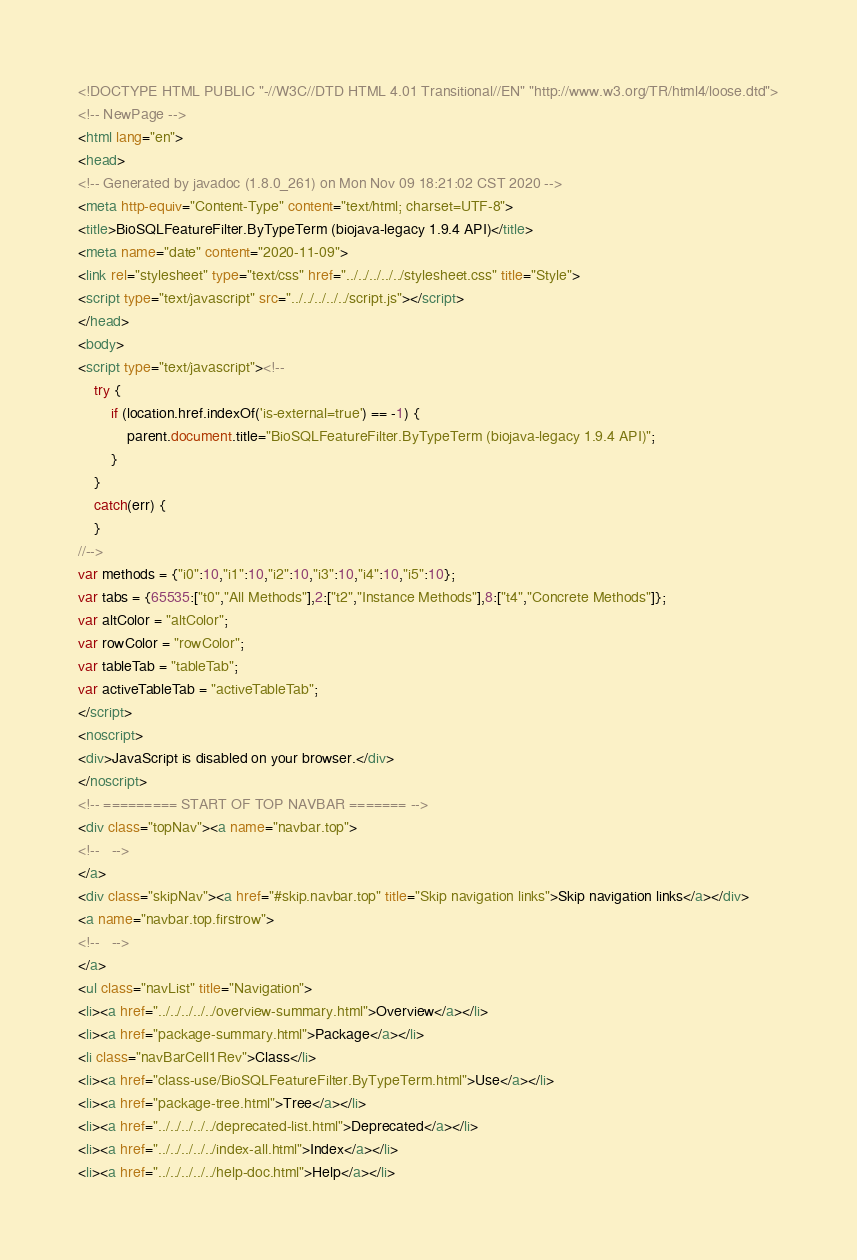Convert code to text. <code><loc_0><loc_0><loc_500><loc_500><_HTML_><!DOCTYPE HTML PUBLIC "-//W3C//DTD HTML 4.01 Transitional//EN" "http://www.w3.org/TR/html4/loose.dtd">
<!-- NewPage -->
<html lang="en">
<head>
<!-- Generated by javadoc (1.8.0_261) on Mon Nov 09 18:21:02 CST 2020 -->
<meta http-equiv="Content-Type" content="text/html; charset=UTF-8">
<title>BioSQLFeatureFilter.ByTypeTerm (biojava-legacy 1.9.4 API)</title>
<meta name="date" content="2020-11-09">
<link rel="stylesheet" type="text/css" href="../../../../../stylesheet.css" title="Style">
<script type="text/javascript" src="../../../../../script.js"></script>
</head>
<body>
<script type="text/javascript"><!--
    try {
        if (location.href.indexOf('is-external=true') == -1) {
            parent.document.title="BioSQLFeatureFilter.ByTypeTerm (biojava-legacy 1.9.4 API)";
        }
    }
    catch(err) {
    }
//-->
var methods = {"i0":10,"i1":10,"i2":10,"i3":10,"i4":10,"i5":10};
var tabs = {65535:["t0","All Methods"],2:["t2","Instance Methods"],8:["t4","Concrete Methods"]};
var altColor = "altColor";
var rowColor = "rowColor";
var tableTab = "tableTab";
var activeTableTab = "activeTableTab";
</script>
<noscript>
<div>JavaScript is disabled on your browser.</div>
</noscript>
<!-- ========= START OF TOP NAVBAR ======= -->
<div class="topNav"><a name="navbar.top">
<!--   -->
</a>
<div class="skipNav"><a href="#skip.navbar.top" title="Skip navigation links">Skip navigation links</a></div>
<a name="navbar.top.firstrow">
<!--   -->
</a>
<ul class="navList" title="Navigation">
<li><a href="../../../../../overview-summary.html">Overview</a></li>
<li><a href="package-summary.html">Package</a></li>
<li class="navBarCell1Rev">Class</li>
<li><a href="class-use/BioSQLFeatureFilter.ByTypeTerm.html">Use</a></li>
<li><a href="package-tree.html">Tree</a></li>
<li><a href="../../../../../deprecated-list.html">Deprecated</a></li>
<li><a href="../../../../../index-all.html">Index</a></li>
<li><a href="../../../../../help-doc.html">Help</a></li></code> 